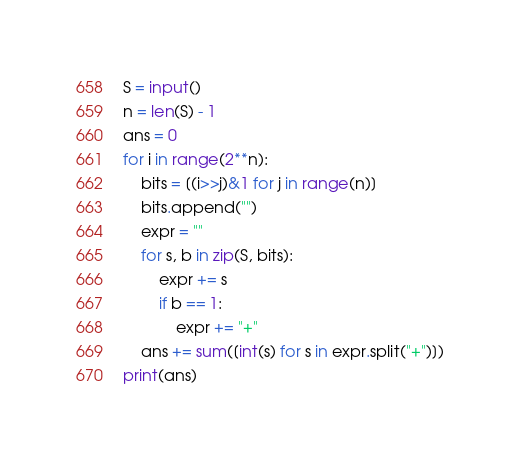<code> <loc_0><loc_0><loc_500><loc_500><_Python_>S = input()
n = len(S) - 1
ans = 0
for i in range(2**n):
    bits = [(i>>j)&1 for j in range(n)]
    bits.append("")
    expr = ""
    for s, b in zip(S, bits):
        expr += s
        if b == 1:
            expr += "+"
    ans += sum([int(s) for s in expr.split("+")])
print(ans)</code> 